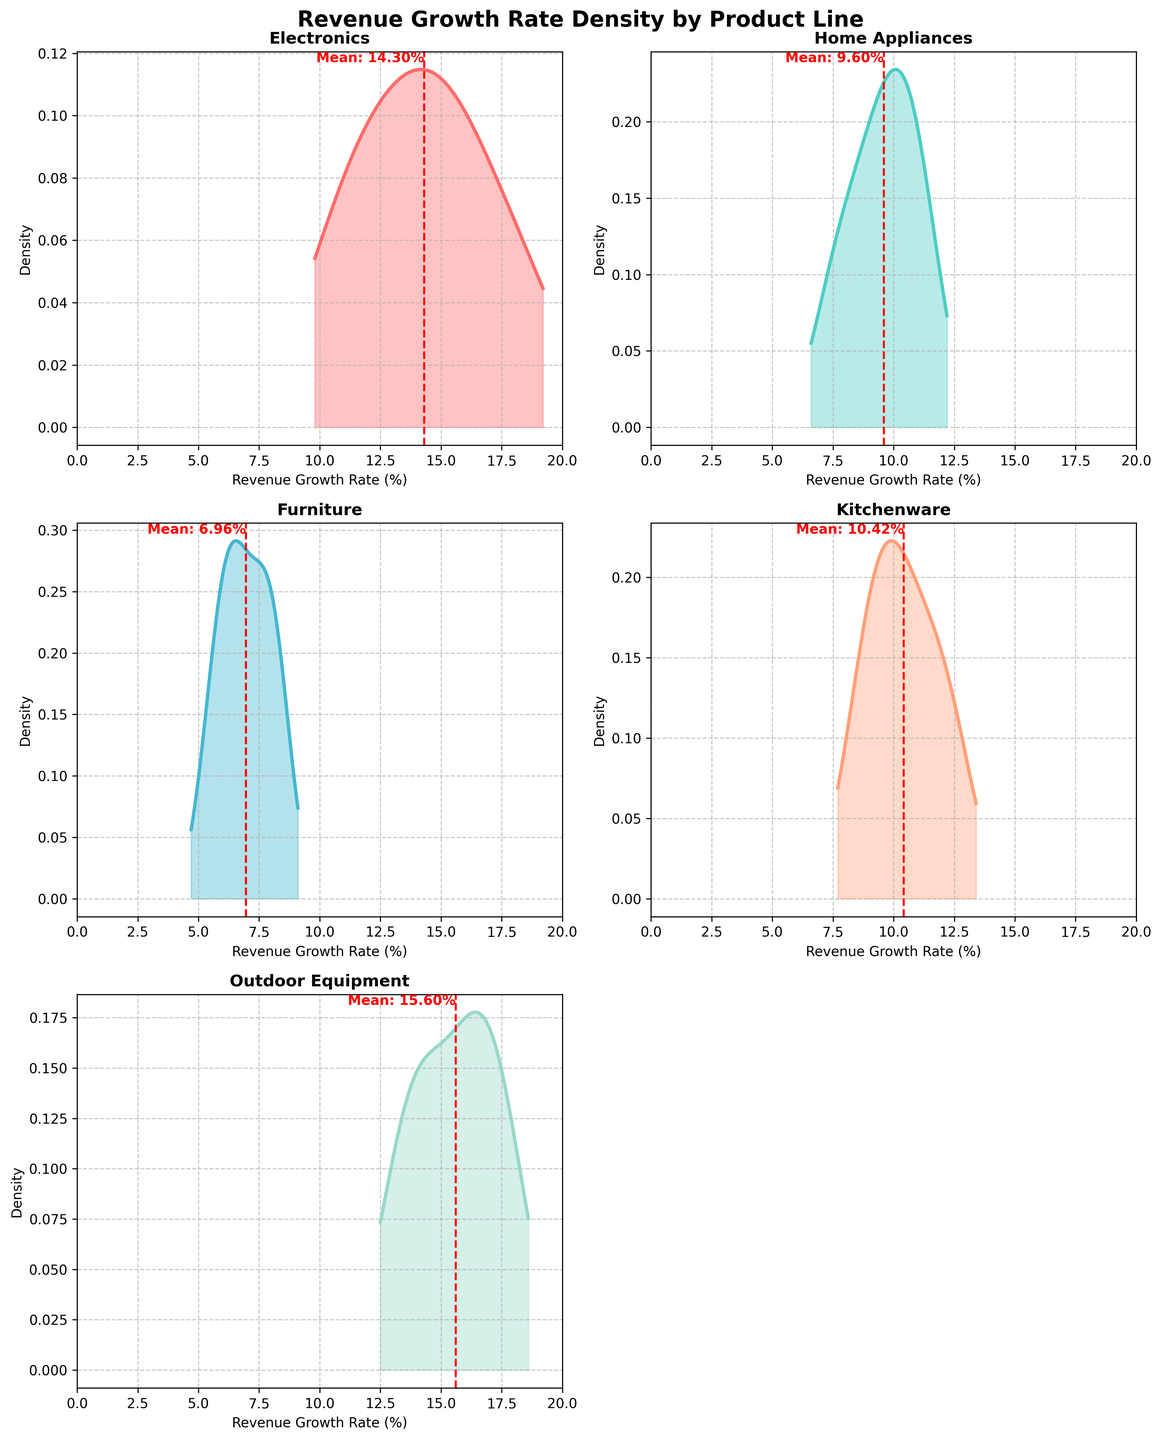How many product lines are displayed in the figure? There are 5 unique product lines in the dataset: Electronics, Home Appliances, Furniture, Kitchenware, and Outdoor Equipment. This matches the number of subplots in the figure.
Answer: 5 What is the title of the figure? The figure's title "Revenue Growth Rate Density by Product Line" is located at the top of the figure in bold and large font size.
Answer: Revenue Growth Rate Density by Product Line Which product line has the highest mean revenue growth rate? The red dashed vertical line indicates the mean. Among the subplots, Outdoor Equipment has the highest mean close to around 15-16%.
Answer: Outdoor Equipment What is the approximate mean revenue growth rate for Home Appliances? From the red dashed line in the Home Appliances subplot, the mean revenue growth rate is around 9.6%.
Answer: 9.6% Which product line has the widest range of revenue growth rates? By observing the x-axis range (from the minimum to maximum x-values covered by density) and density spread, Electronics has the widest range extending from about 10% to 18%.
Answer: Electronics Does Kitchenware or Furniture have a higher peak density? Comparing the subplots, Kitchenware has a higher peak density than Furniture, indicating that Kitchenware's revenue growth rates are more concentrated around its mean.
Answer: Kitchenware Which product line has the most data points close to the mean? The density plot with the highest peak close to the mean represents the most concentration near the mean. Kitchenware has the most data points concentrated near the mean with a sharper peak around its mean value compared to others.
Answer: Kitchenware What is the x-axis labeled as? The x-axis across all subplots is consistently labeled as "Revenue Growth Rate (%)".
Answer: Revenue Growth Rate (%) Which product line has the lowest mean revenue growth rate? By examining the red dashed mean lines in each subplot, Furniture has the lowest mean revenue growth rate around 6.96%.
Answer: Furniture 